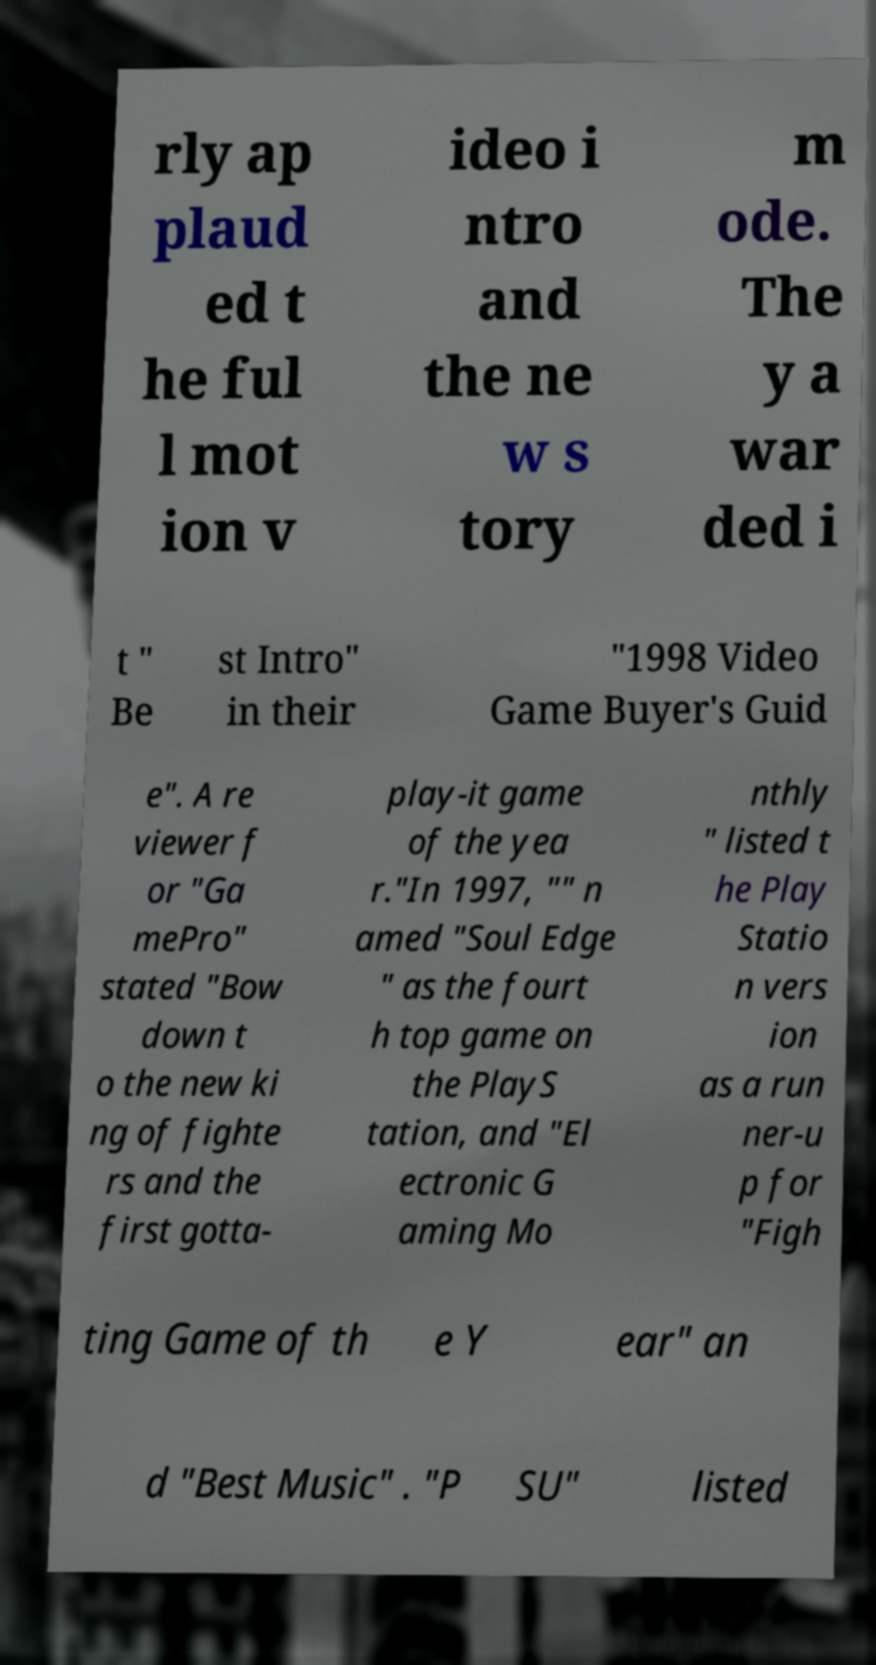For documentation purposes, I need the text within this image transcribed. Could you provide that? rly ap plaud ed t he ful l mot ion v ideo i ntro and the ne w s tory m ode. The y a war ded i t " Be st Intro" in their "1998 Video Game Buyer's Guid e". A re viewer f or "Ga mePro" stated "Bow down t o the new ki ng of fighte rs and the first gotta- play-it game of the yea r."In 1997, "" n amed "Soul Edge " as the fourt h top game on the PlayS tation, and "El ectronic G aming Mo nthly " listed t he Play Statio n vers ion as a run ner-u p for "Figh ting Game of th e Y ear" an d "Best Music" . "P SU" listed 